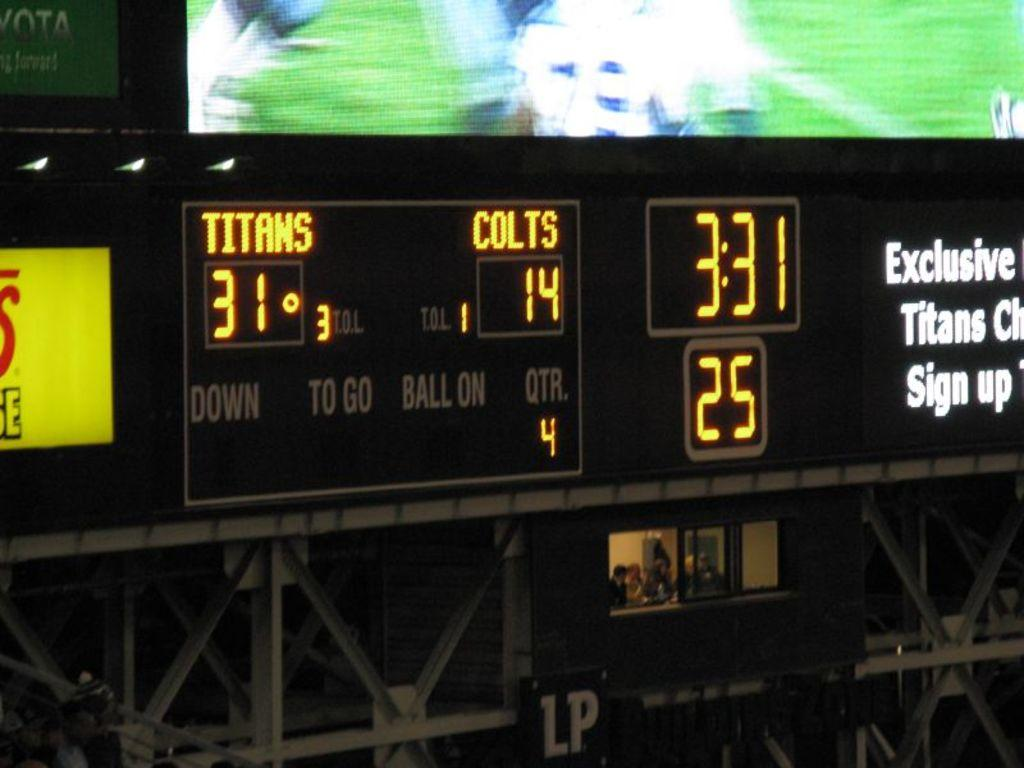Provide a one-sentence caption for the provided image. the time of 3:31 that is on a clock. 